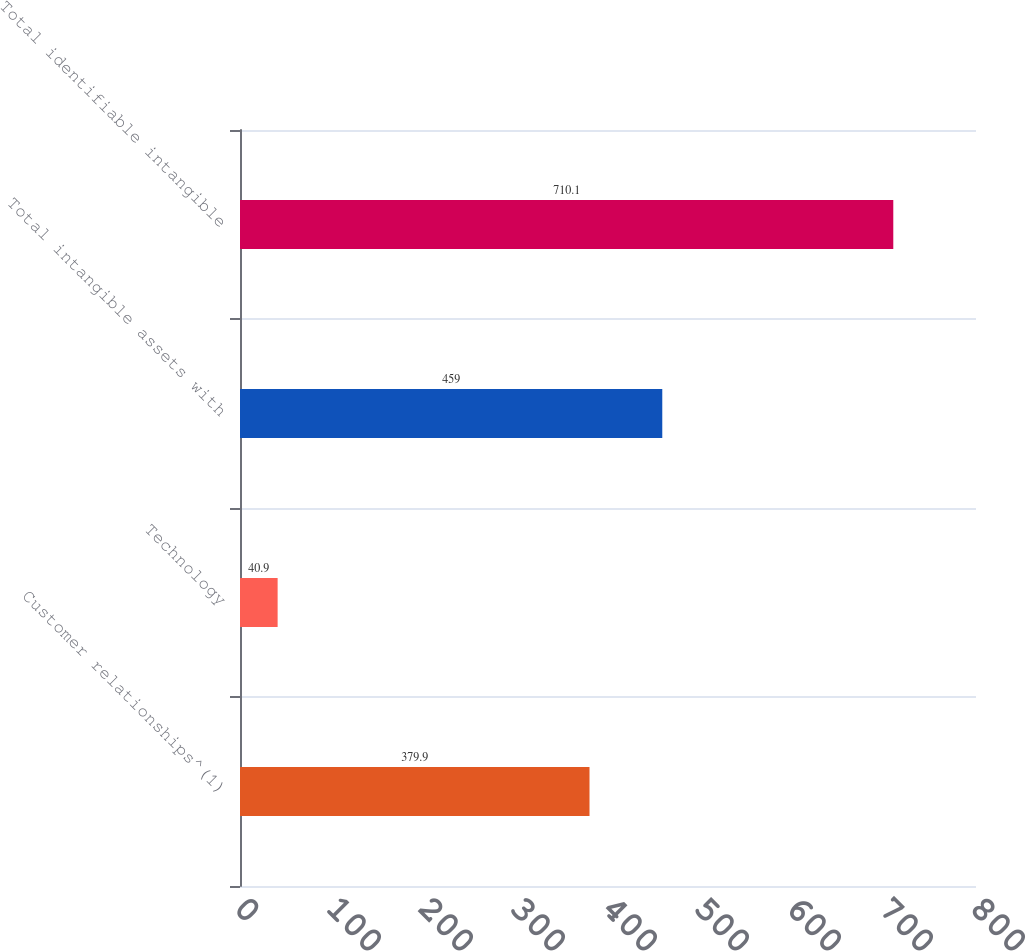<chart> <loc_0><loc_0><loc_500><loc_500><bar_chart><fcel>Customer relationships^(1)<fcel>Technology<fcel>Total intangible assets with<fcel>Total identifiable intangible<nl><fcel>379.9<fcel>40.9<fcel>459<fcel>710.1<nl></chart> 